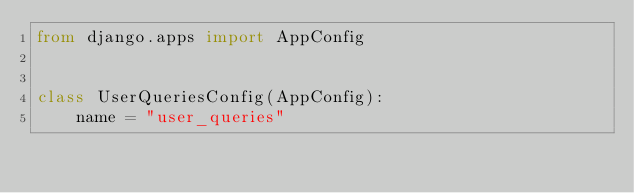<code> <loc_0><loc_0><loc_500><loc_500><_Python_>from django.apps import AppConfig


class UserQueriesConfig(AppConfig):
    name = "user_queries"
</code> 